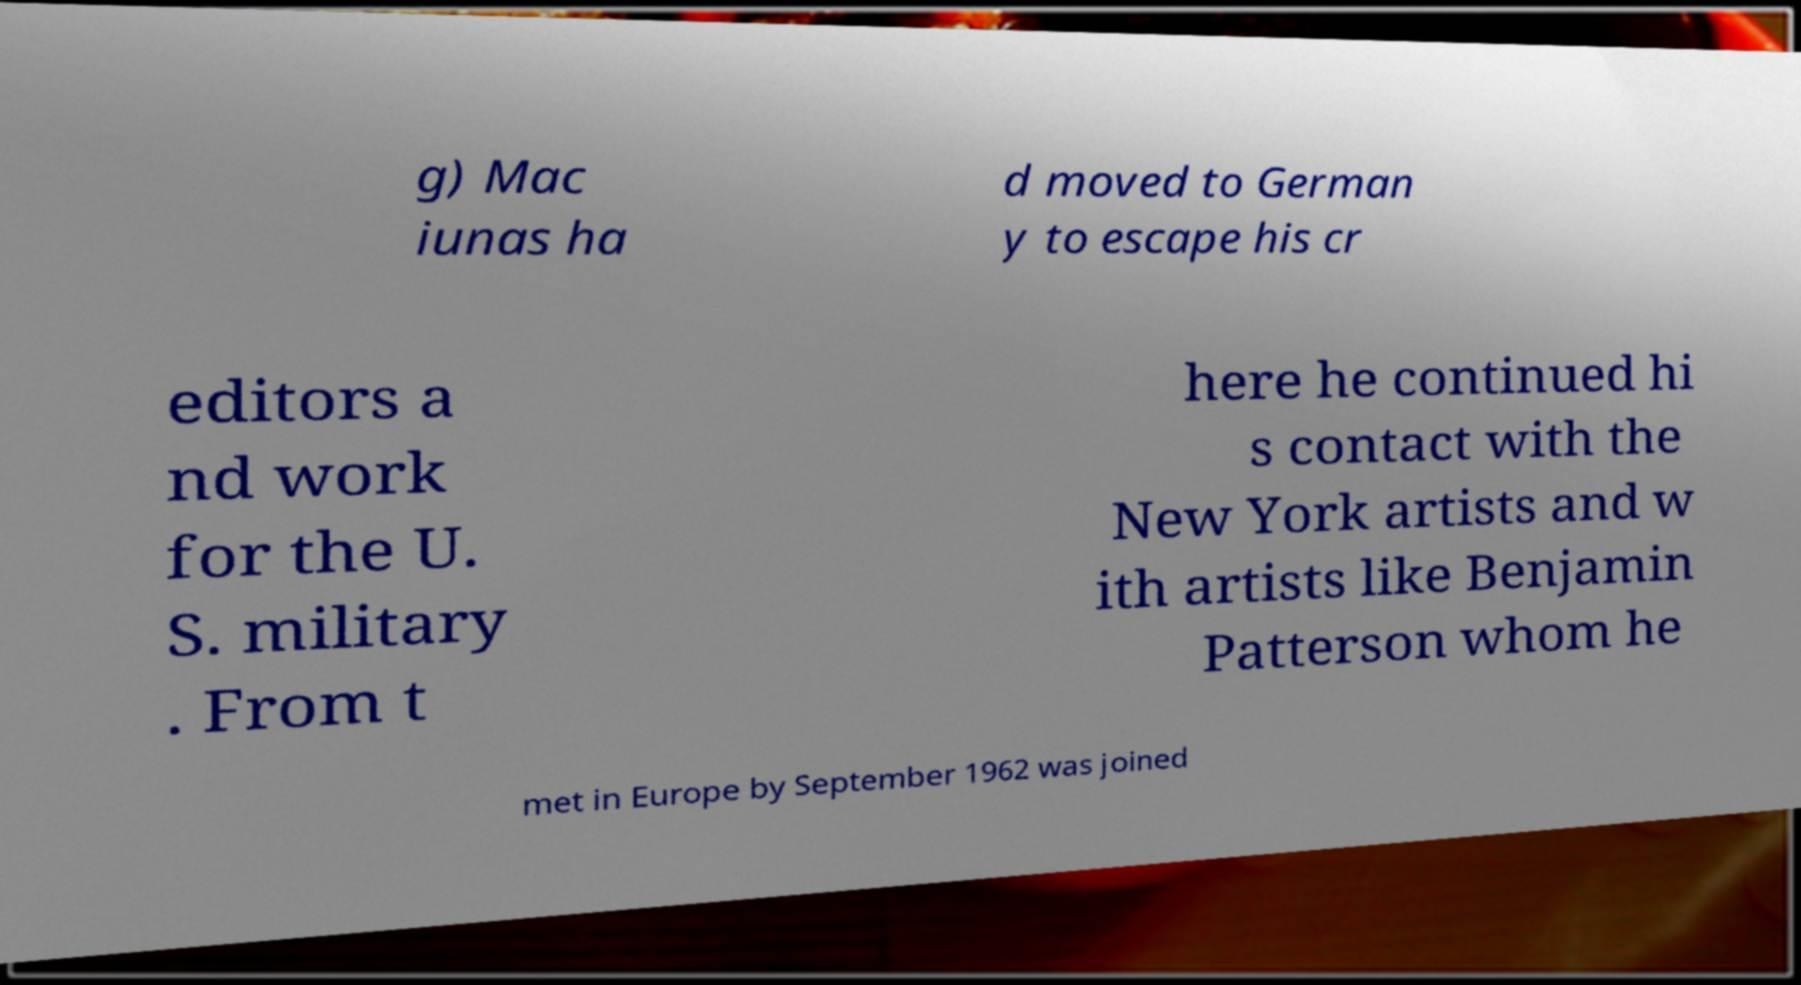Please identify and transcribe the text found in this image. g) Mac iunas ha d moved to German y to escape his cr editors a nd work for the U. S. military . From t here he continued hi s contact with the New York artists and w ith artists like Benjamin Patterson whom he met in Europe by September 1962 was joined 